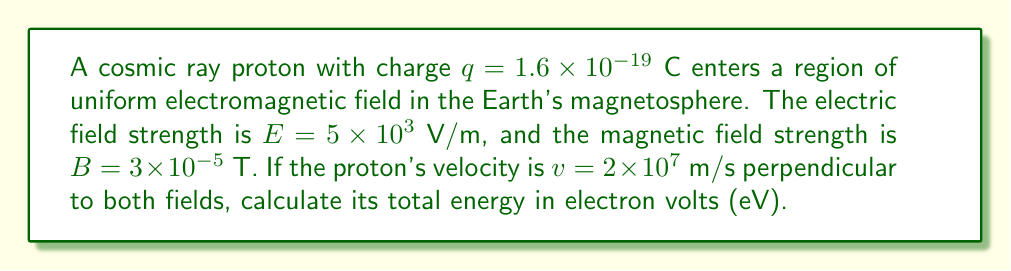Teach me how to tackle this problem. To solve this problem, we'll follow these steps:

1) The total energy of a charged particle in an electromagnetic field is the sum of its kinetic energy and potential energy:

   $$E_{total} = E_{kinetic} + E_{potential}$$

2) Kinetic energy is given by:

   $$E_{kinetic} = \frac{1}{2}mv^2$$

   Where $m$ is the mass of a proton: $1.67 \times 10^{-27}$ kg

3) Calculate kinetic energy:

   $$E_{kinetic} = \frac{1}{2}(1.67 \times 10^{-27})(2 \times 10^7)^2 = 3.34 \times 10^{-13}\ \text{J}$$

4) Potential energy in an electric field is:

   $$E_{potential} = qEd$$

   Where $d$ is the distance traveled. We don't know $d$, but we can use the work-energy theorem to find the change in potential energy over time $t$:

   $$\Delta E_{potential} = qEvt$$

5) The magnetic field doesn't contribute to the energy directly, but it affects the particle's path. The particle will move in a circular path with radius:

   $$r = \frac{mv}{qB}$$

6) The time for one revolution is:

   $$T = \frac{2\pi r}{v} = \frac{2\pi m}{qB}$$

7) In one revolution, the change in potential energy is:

   $$\Delta E_{potential} = qEvT = qEv\frac{2\pi m}{qB} = \frac{2\pi mvE}{B}$$

8) Calculate this change:

   $$\Delta E_{potential} = \frac{2\pi (1.67 \times 10^{-27})(2 \times 10^7)(5 \times 10^3)}{3 \times 10^{-5}} = 3.50 \times 10^{-13}\ \text{J}$$

9) Total energy:

   $$E_{total} = E_{kinetic} + \Delta E_{potential} = 3.34 \times 10^{-13} + 3.50 \times 10^{-13} = 6.84 \times 10^{-13}\ \text{J}$$

10) Convert to eV (1 eV = $1.6 \times 10^{-19}$ J):

    $$E_{total} = \frac{6.84 \times 10^{-13}}{1.6 \times 10^{-19}} = 4.28 \times 10^6\ \text{eV} = 4.28\ \text{MeV}$$
Answer: 4.28 MeV 